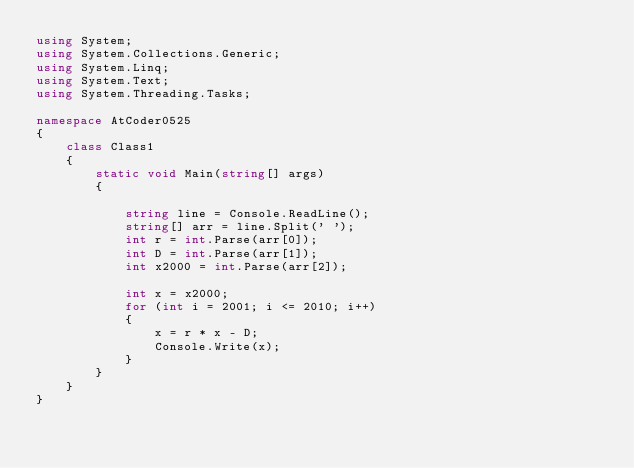<code> <loc_0><loc_0><loc_500><loc_500><_C#_>using System;
using System.Collections.Generic;
using System.Linq;
using System.Text;
using System.Threading.Tasks;

namespace AtCoder0525
{
    class Class1
    {
        static void Main(string[] args)
        {

            string line = Console.ReadLine();
            string[] arr = line.Split(' ');
            int r = int.Parse(arr[0]);
            int D = int.Parse(arr[1]);
            int x2000 = int.Parse(arr[2]);

            int x = x2000;
            for (int i = 2001; i <= 2010; i++)
            {
                x = r * x - D;
                Console.Write(x);
            }
        }
    }
}
</code> 